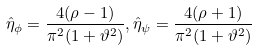Convert formula to latex. <formula><loc_0><loc_0><loc_500><loc_500>\hat { \eta } _ { \phi } = \frac { 4 ( \rho - 1 ) } { \pi ^ { 2 } ( 1 + \vartheta ^ { 2 } ) } , \hat { \eta } _ { \psi } = \frac { 4 ( \rho + 1 ) } { \pi ^ { 2 } ( 1 + \vartheta ^ { 2 } ) }</formula> 